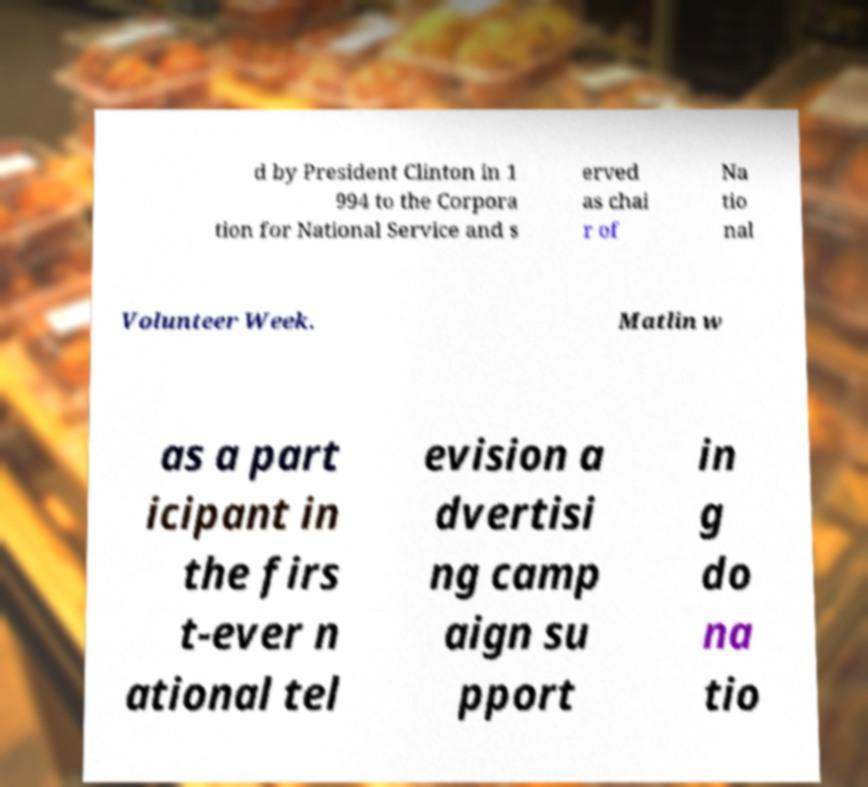Can you accurately transcribe the text from the provided image for me? d by President Clinton in 1 994 to the Corpora tion for National Service and s erved as chai r of Na tio nal Volunteer Week. Matlin w as a part icipant in the firs t-ever n ational tel evision a dvertisi ng camp aign su pport in g do na tio 